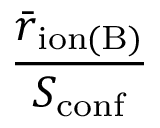<formula> <loc_0><loc_0><loc_500><loc_500>\frac { \bar { r } _ { i o n ( B ) } } { S _ { c o n f } }</formula> 